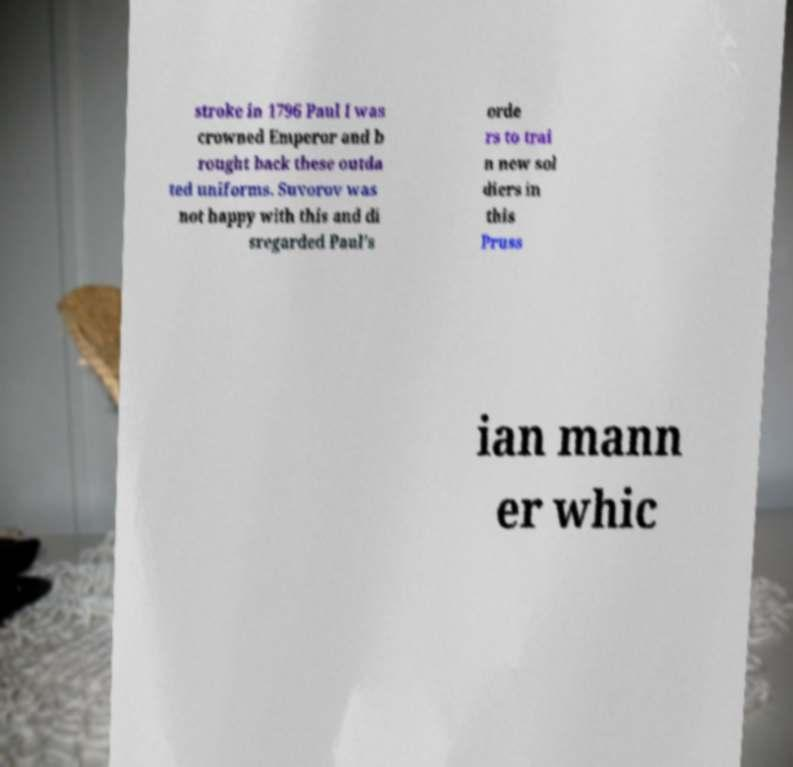Could you assist in decoding the text presented in this image and type it out clearly? stroke in 1796 Paul I was crowned Emperor and b rought back these outda ted uniforms. Suvorov was not happy with this and di sregarded Paul's orde rs to trai n new sol diers in this Pruss ian mann er whic 